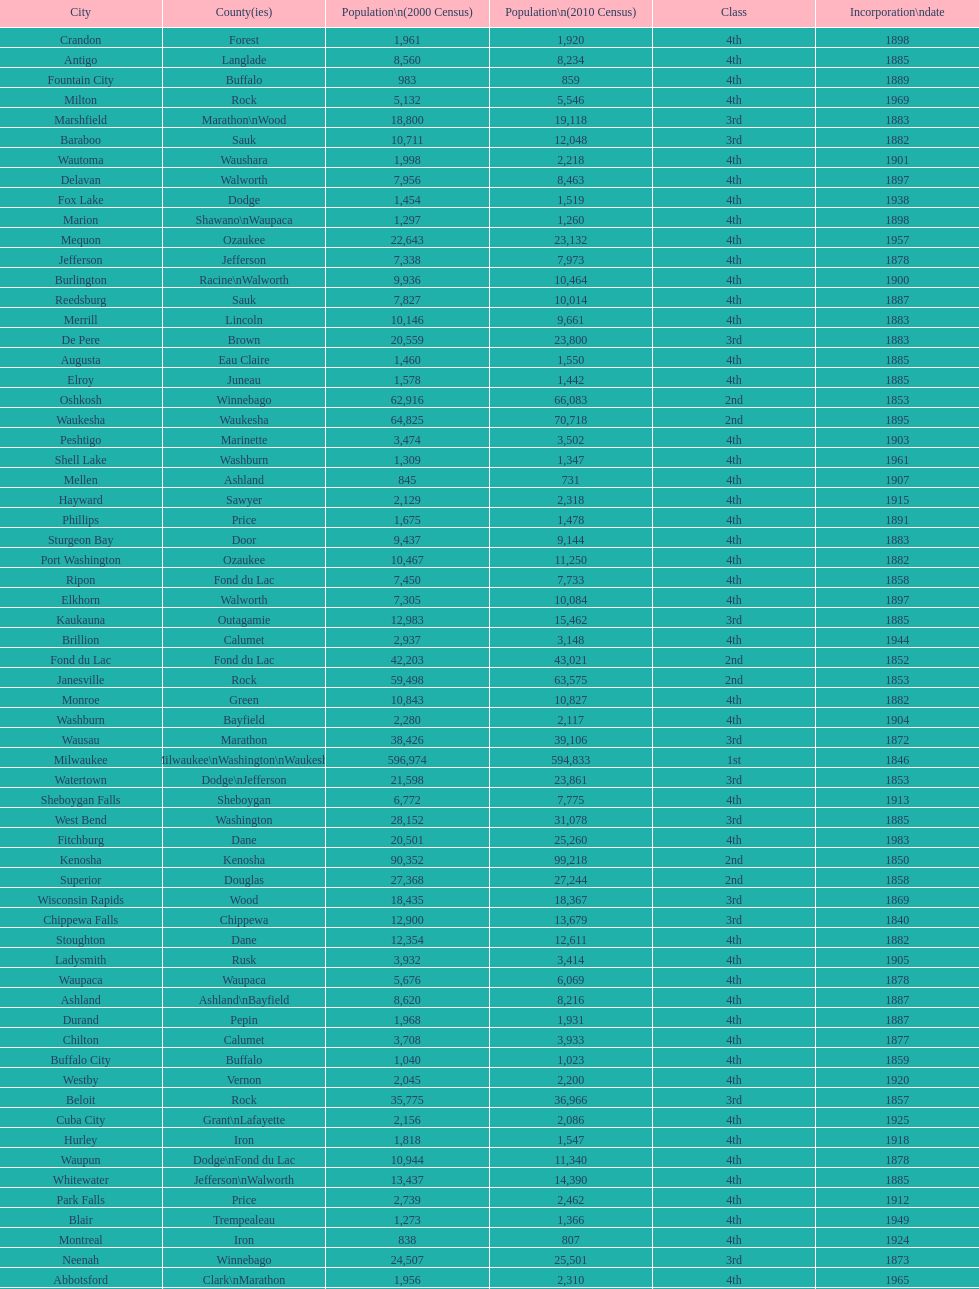How many cities are in wisconsin? 190. 